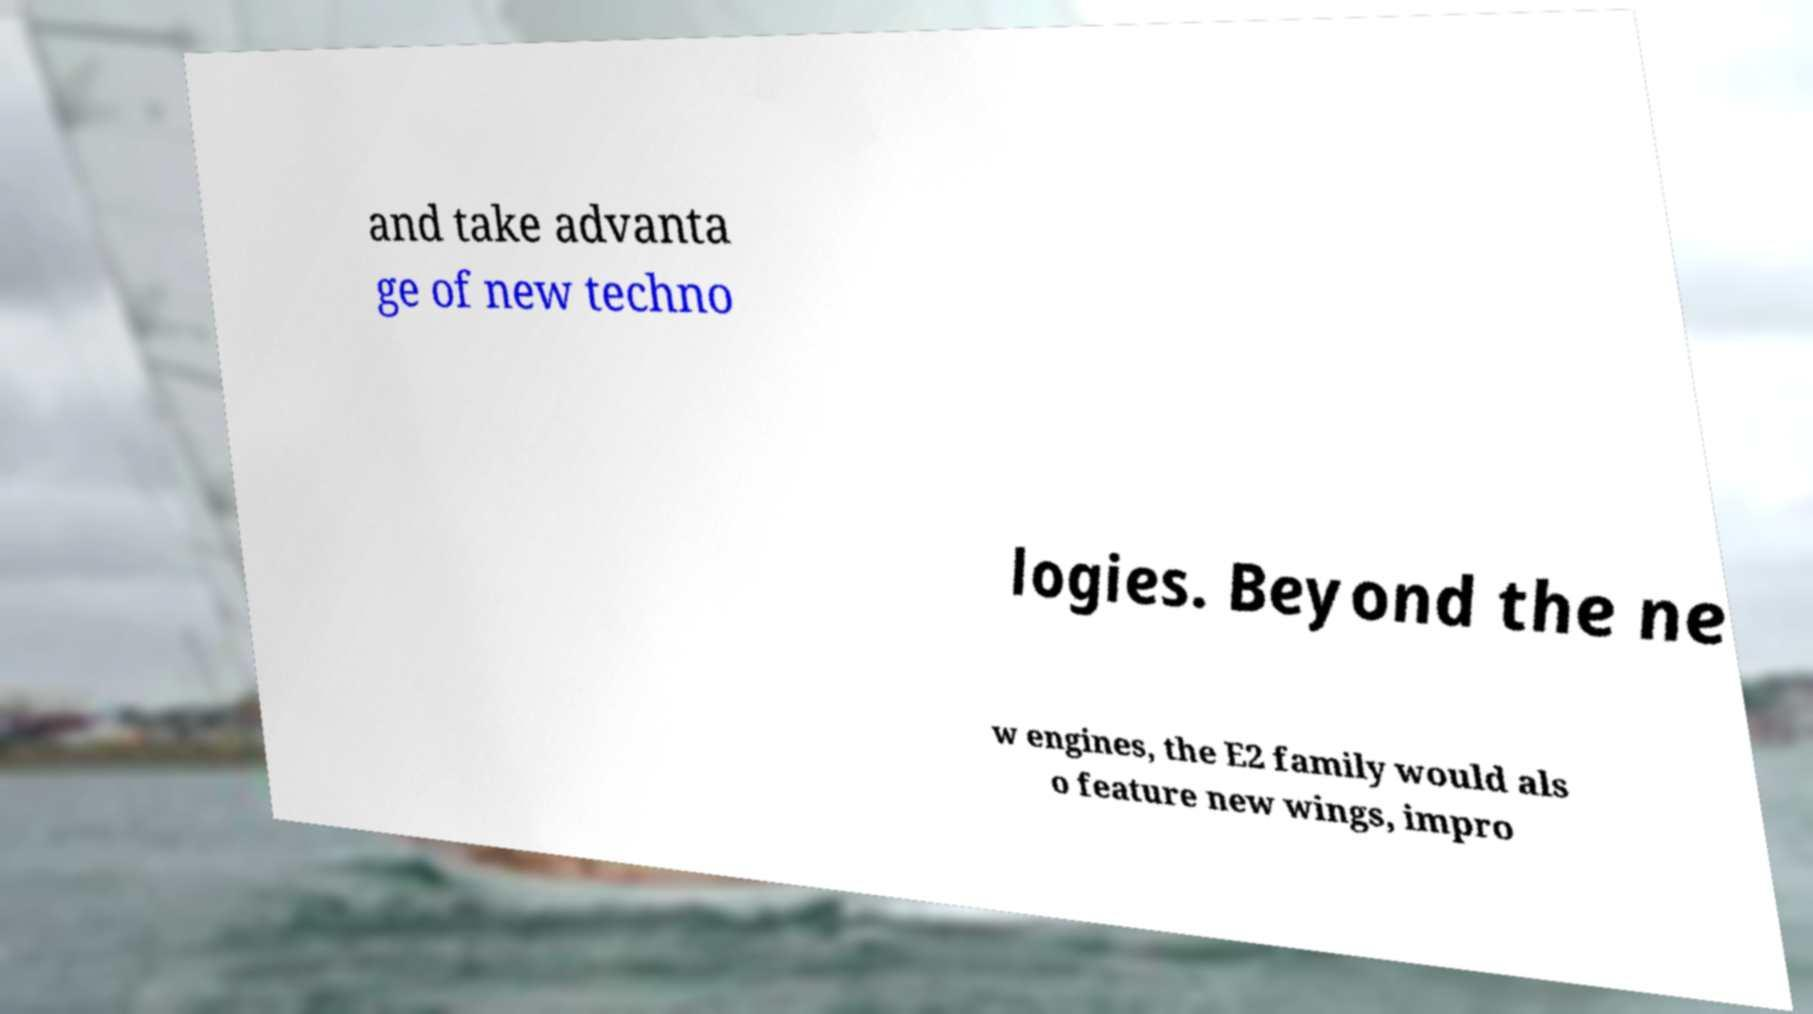There's text embedded in this image that I need extracted. Can you transcribe it verbatim? and take advanta ge of new techno logies. Beyond the ne w engines, the E2 family would als o feature new wings, impro 